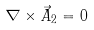<formula> <loc_0><loc_0><loc_500><loc_500>\nabla \times \vec { A } _ { 2 } = 0</formula> 